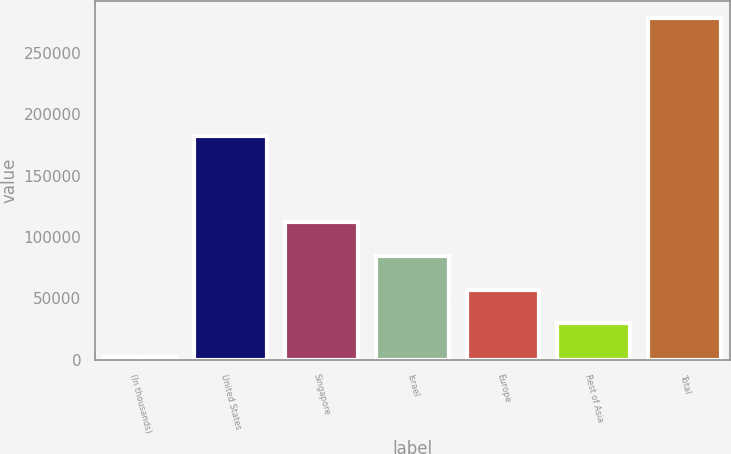Convert chart to OTSL. <chart><loc_0><loc_0><loc_500><loc_500><bar_chart><fcel>(In thousands)<fcel>United States<fcel>Singapore<fcel>Israel<fcel>Europe<fcel>Rest of Asia<fcel>Total<nl><fcel>2016<fcel>182597<fcel>112415<fcel>84815.4<fcel>57215.6<fcel>29615.8<fcel>278014<nl></chart> 